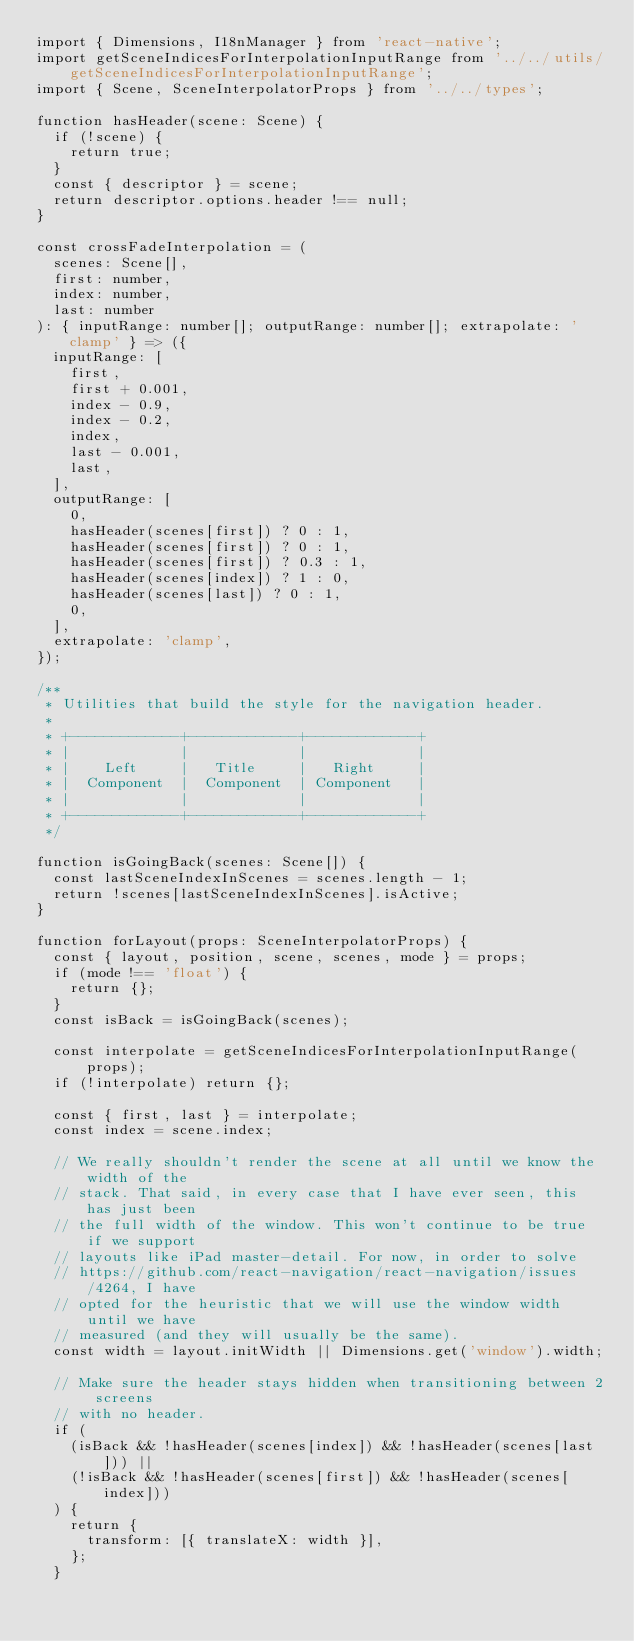<code> <loc_0><loc_0><loc_500><loc_500><_TypeScript_>import { Dimensions, I18nManager } from 'react-native';
import getSceneIndicesForInterpolationInputRange from '../../utils/getSceneIndicesForInterpolationInputRange';
import { Scene, SceneInterpolatorProps } from '../../types';

function hasHeader(scene: Scene) {
  if (!scene) {
    return true;
  }
  const { descriptor } = scene;
  return descriptor.options.header !== null;
}

const crossFadeInterpolation = (
  scenes: Scene[],
  first: number,
  index: number,
  last: number
): { inputRange: number[]; outputRange: number[]; extrapolate: 'clamp' } => ({
  inputRange: [
    first,
    first + 0.001,
    index - 0.9,
    index - 0.2,
    index,
    last - 0.001,
    last,
  ],
  outputRange: [
    0,
    hasHeader(scenes[first]) ? 0 : 1,
    hasHeader(scenes[first]) ? 0 : 1,
    hasHeader(scenes[first]) ? 0.3 : 1,
    hasHeader(scenes[index]) ? 1 : 0,
    hasHeader(scenes[last]) ? 0 : 1,
    0,
  ],
  extrapolate: 'clamp',
});

/**
 * Utilities that build the style for the navigation header.
 *
 * +-------------+-------------+-------------+
 * |             |             |             |
 * |    Left     |   Title     |   Right     |
 * |  Component  |  Component  | Component   |
 * |             |             |             |
 * +-------------+-------------+-------------+
 */

function isGoingBack(scenes: Scene[]) {
  const lastSceneIndexInScenes = scenes.length - 1;
  return !scenes[lastSceneIndexInScenes].isActive;
}

function forLayout(props: SceneInterpolatorProps) {
  const { layout, position, scene, scenes, mode } = props;
  if (mode !== 'float') {
    return {};
  }
  const isBack = isGoingBack(scenes);

  const interpolate = getSceneIndicesForInterpolationInputRange(props);
  if (!interpolate) return {};

  const { first, last } = interpolate;
  const index = scene.index;

  // We really shouldn't render the scene at all until we know the width of the
  // stack. That said, in every case that I have ever seen, this has just been
  // the full width of the window. This won't continue to be true if we support
  // layouts like iPad master-detail. For now, in order to solve
  // https://github.com/react-navigation/react-navigation/issues/4264, I have
  // opted for the heuristic that we will use the window width until we have
  // measured (and they will usually be the same).
  const width = layout.initWidth || Dimensions.get('window').width;

  // Make sure the header stays hidden when transitioning between 2 screens
  // with no header.
  if (
    (isBack && !hasHeader(scenes[index]) && !hasHeader(scenes[last])) ||
    (!isBack && !hasHeader(scenes[first]) && !hasHeader(scenes[index]))
  ) {
    return {
      transform: [{ translateX: width }],
    };
  }
</code> 